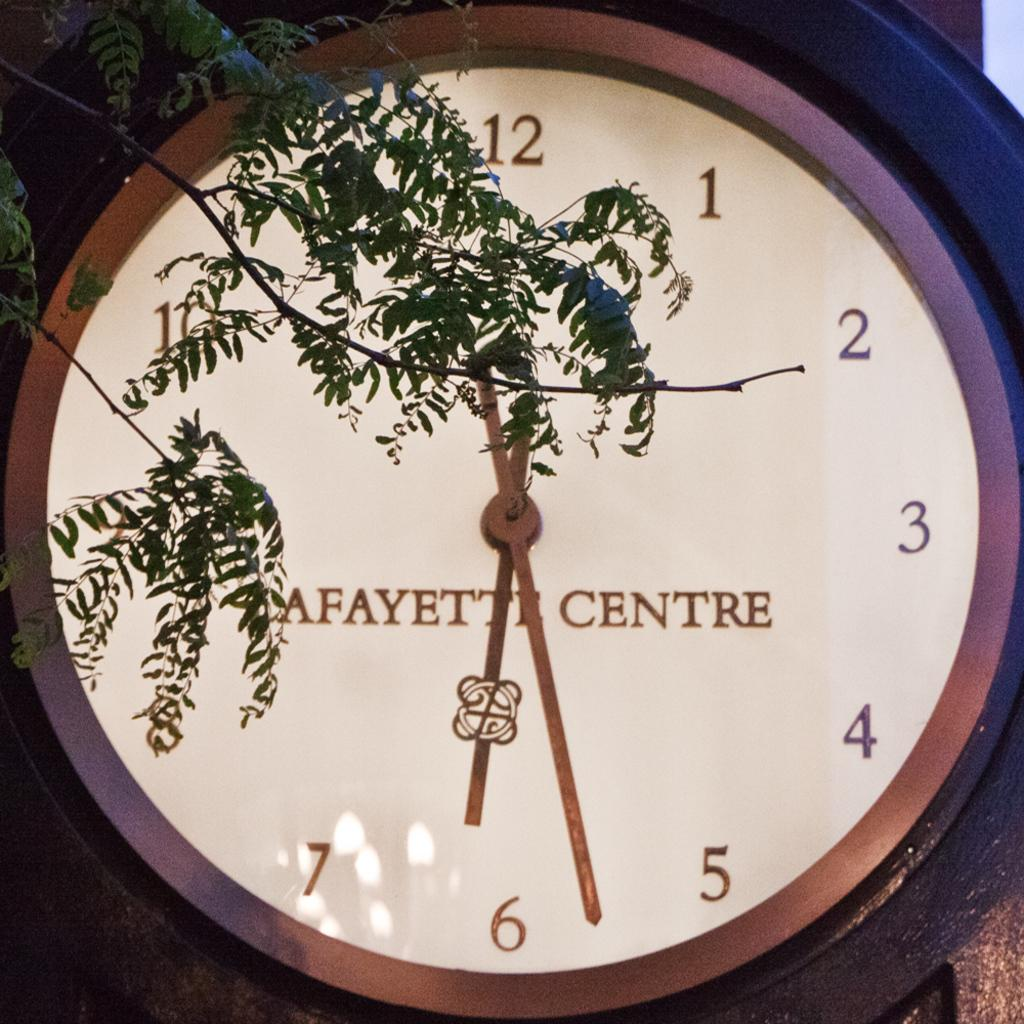<image>
Give a short and clear explanation of the subsequent image. a clock that has lafayette centre on it 